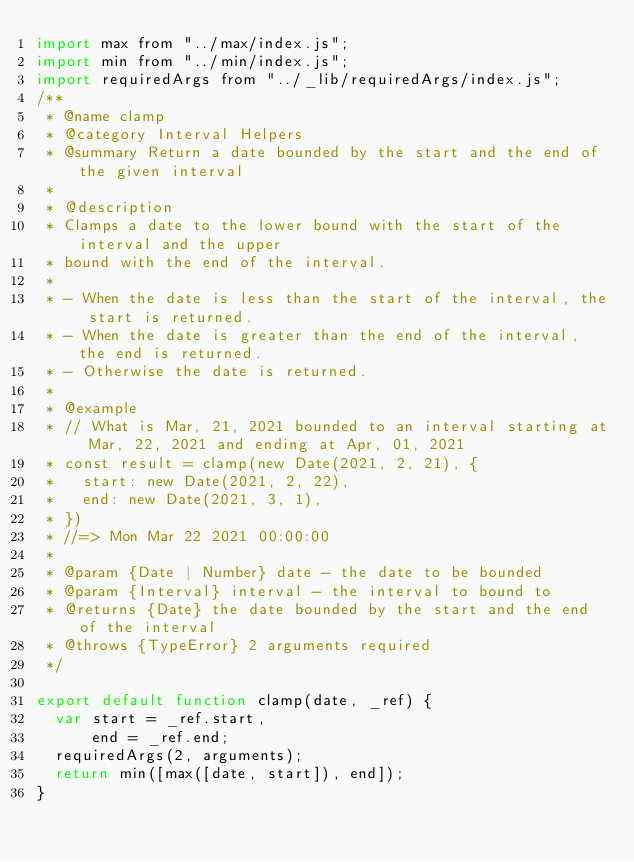Convert code to text. <code><loc_0><loc_0><loc_500><loc_500><_JavaScript_>import max from "../max/index.js";
import min from "../min/index.js";
import requiredArgs from "../_lib/requiredArgs/index.js";
/**
 * @name clamp
 * @category Interval Helpers
 * @summary Return a date bounded by the start and the end of the given interval
 *
 * @description
 * Clamps a date to the lower bound with the start of the interval and the upper
 * bound with the end of the interval.
 *
 * - When the date is less than the start of the interval, the start is returned.
 * - When the date is greater than the end of the interval, the end is returned.
 * - Otherwise the date is returned.
 *
 * @example
 * // What is Mar, 21, 2021 bounded to an interval starting at Mar, 22, 2021 and ending at Apr, 01, 2021
 * const result = clamp(new Date(2021, 2, 21), {
 *   start: new Date(2021, 2, 22),
 *   end: new Date(2021, 3, 1),
 * })
 * //=> Mon Mar 22 2021 00:00:00
 *
 * @param {Date | Number} date - the date to be bounded
 * @param {Interval} interval - the interval to bound to
 * @returns {Date} the date bounded by the start and the end of the interval
 * @throws {TypeError} 2 arguments required
 */

export default function clamp(date, _ref) {
  var start = _ref.start,
      end = _ref.end;
  requiredArgs(2, arguments);
  return min([max([date, start]), end]);
}</code> 